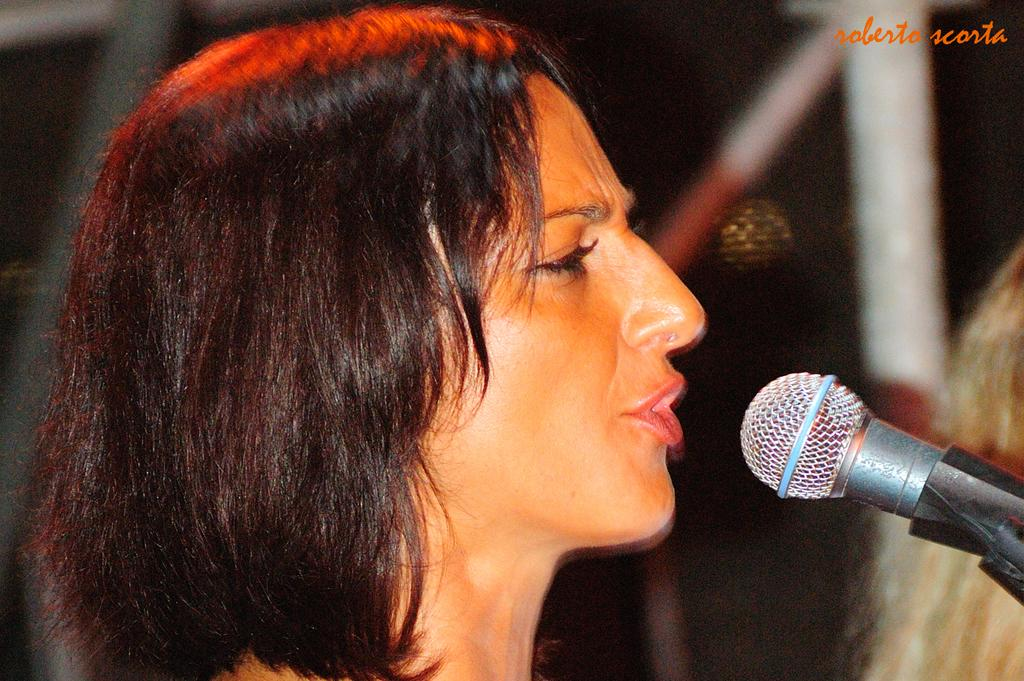Who is the main subject in the image? There is a woman in the image. What is the woman doing in the image? The woman appears to be singing. What object is in front of the woman? There is a microphone in front of the woman. Can you describe the background of the image? The background of the woman is blurred. Where is the pen located in the image? There is no pen present in the image. Can you see any animals from the zoo in the image? There are no animals from the zoo visible in the image. 